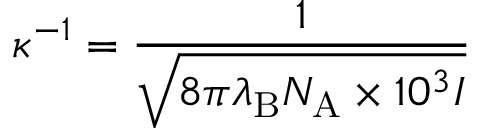Convert formula to latex. <formula><loc_0><loc_0><loc_500><loc_500>\kappa ^ { - 1 } = { \frac { 1 } { \sqrt { 8 \pi \lambda _ { B } N _ { A } \times 1 0 ^ { 3 } I } } }</formula> 